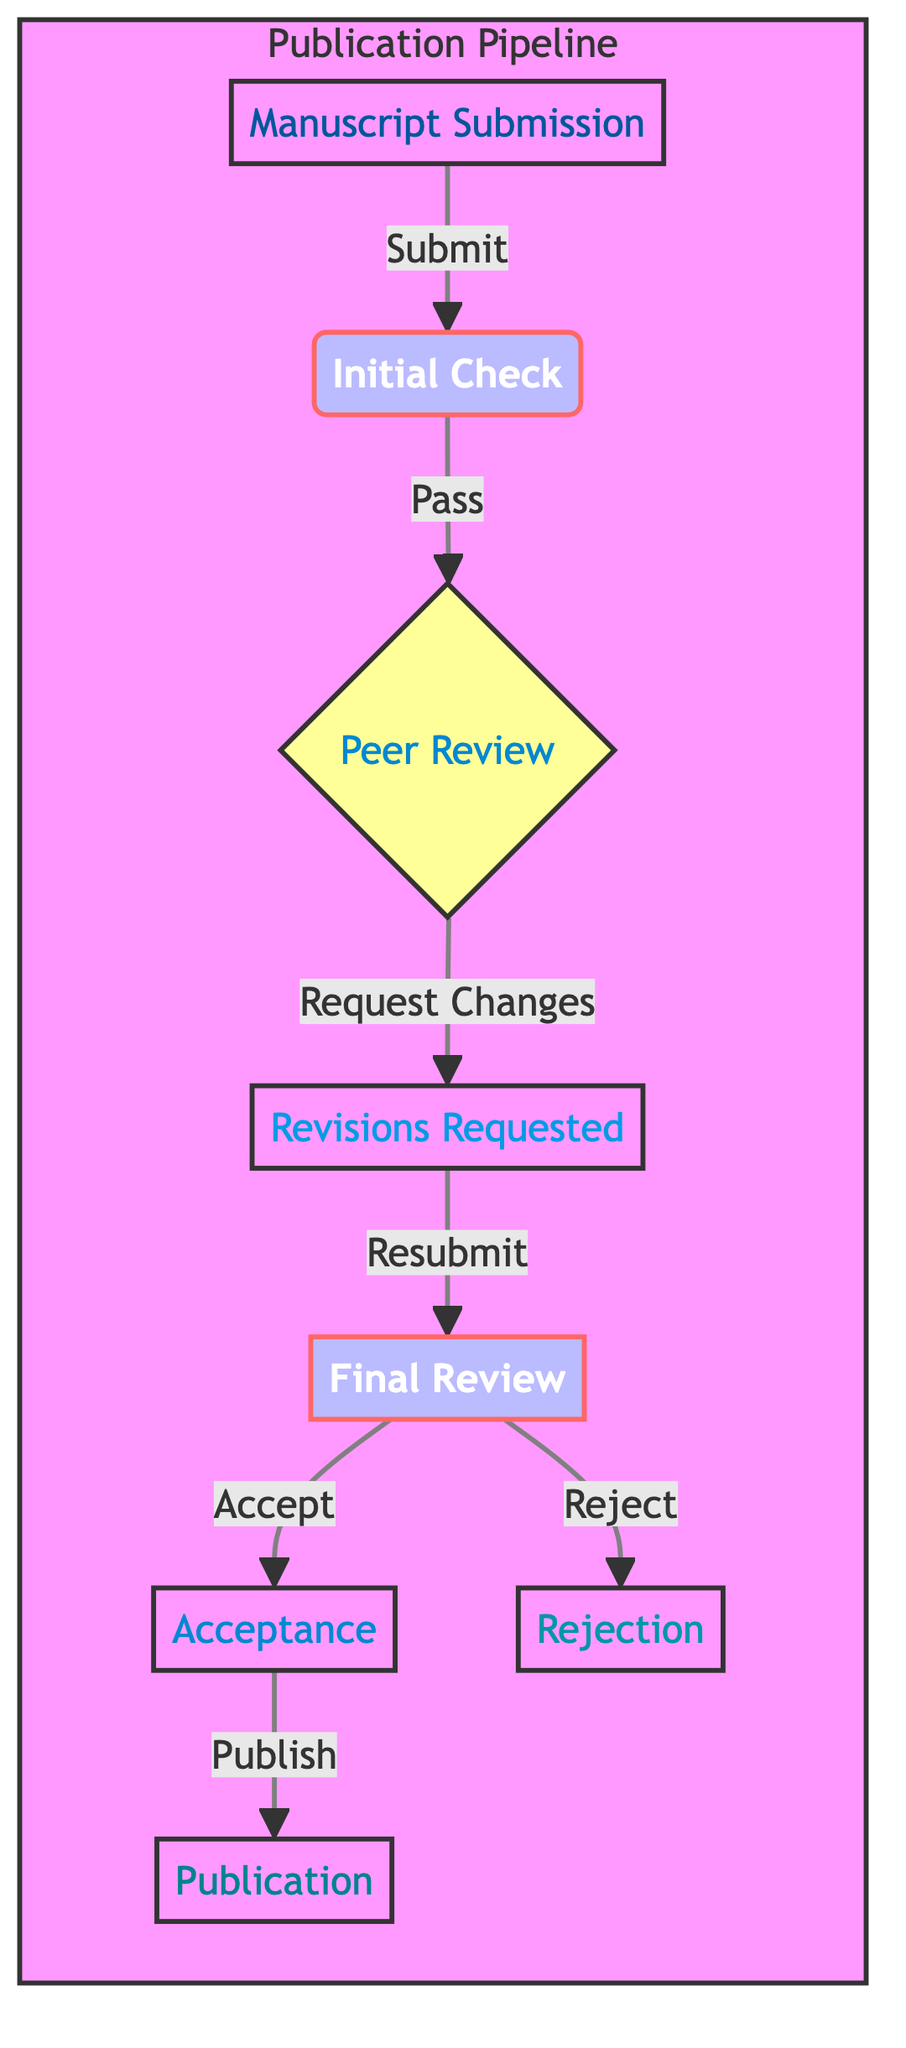What is the first stage in the publication pipeline? The first stage in the pipeline is represented by the node labeled "Manuscript Submission". This is clearly indicated as the starting point of the diagram.
Answer: Manuscript Submission How many nodes are there in the directed graph? The diagram lists a total of eight individual nodes: Manuscript Submission, Initial Check, Peer Review, Revisions Requested, Final Review, Acceptance, Publication, and Rejection. Counting all of these gives a total of eight nodes.
Answer: 8 What is the last stage before the publication? The last stage before publication is the "Acceptance" node. "Acceptance" is directly connected to "Publication" and represents the final approval before the manuscript is published.
Answer: Acceptance Which stage follows "Revisions Requested"? According to the directed flow, the stage that follows "Revisions Requested" is "Final Review". This is indicated by the directed edge leading from "Revisions Requested" to "Final Review".
Answer: Final Review What are the possible outcomes after the final review? After the "Final Review", there are two possible outcomes: "Acceptance" and "Rejection". This is depicted as branching from the "Final Review" node to these two nodes.
Answer: Acceptance, Rejection How many edges are in the graph? The edges represent the connections between the nodes. By reviewing the relationships listed in the diagram, we can see there are seven directed edges connecting the various stages in the publication process.
Answer: 7 What relationship does the "Initial Check" have with "Peer Review"? "Initial Check" leads directly to "Peer Review" as it is the next stage. The directed edge signifies that after an initial check, the manuscript moves on to peer review, which is a critical stage in the evaluation.
Answer: Leads to Which node is a decision point in the pipeline? The "Peer Review" node functions as the decision point as it determines if revisions are needed (leading to "Revisions Requested") or if the manuscript continues to "Final Review". Its branching outcome illustrates a choice in the process.
Answer: Peer Review What does the "Final Review" lead to if accepted? If the "Final Review" results in acceptance, it leads directly to the "Publication" node, indicating that the manuscript is ready to be published after receiving final approval.
Answer: Publication 